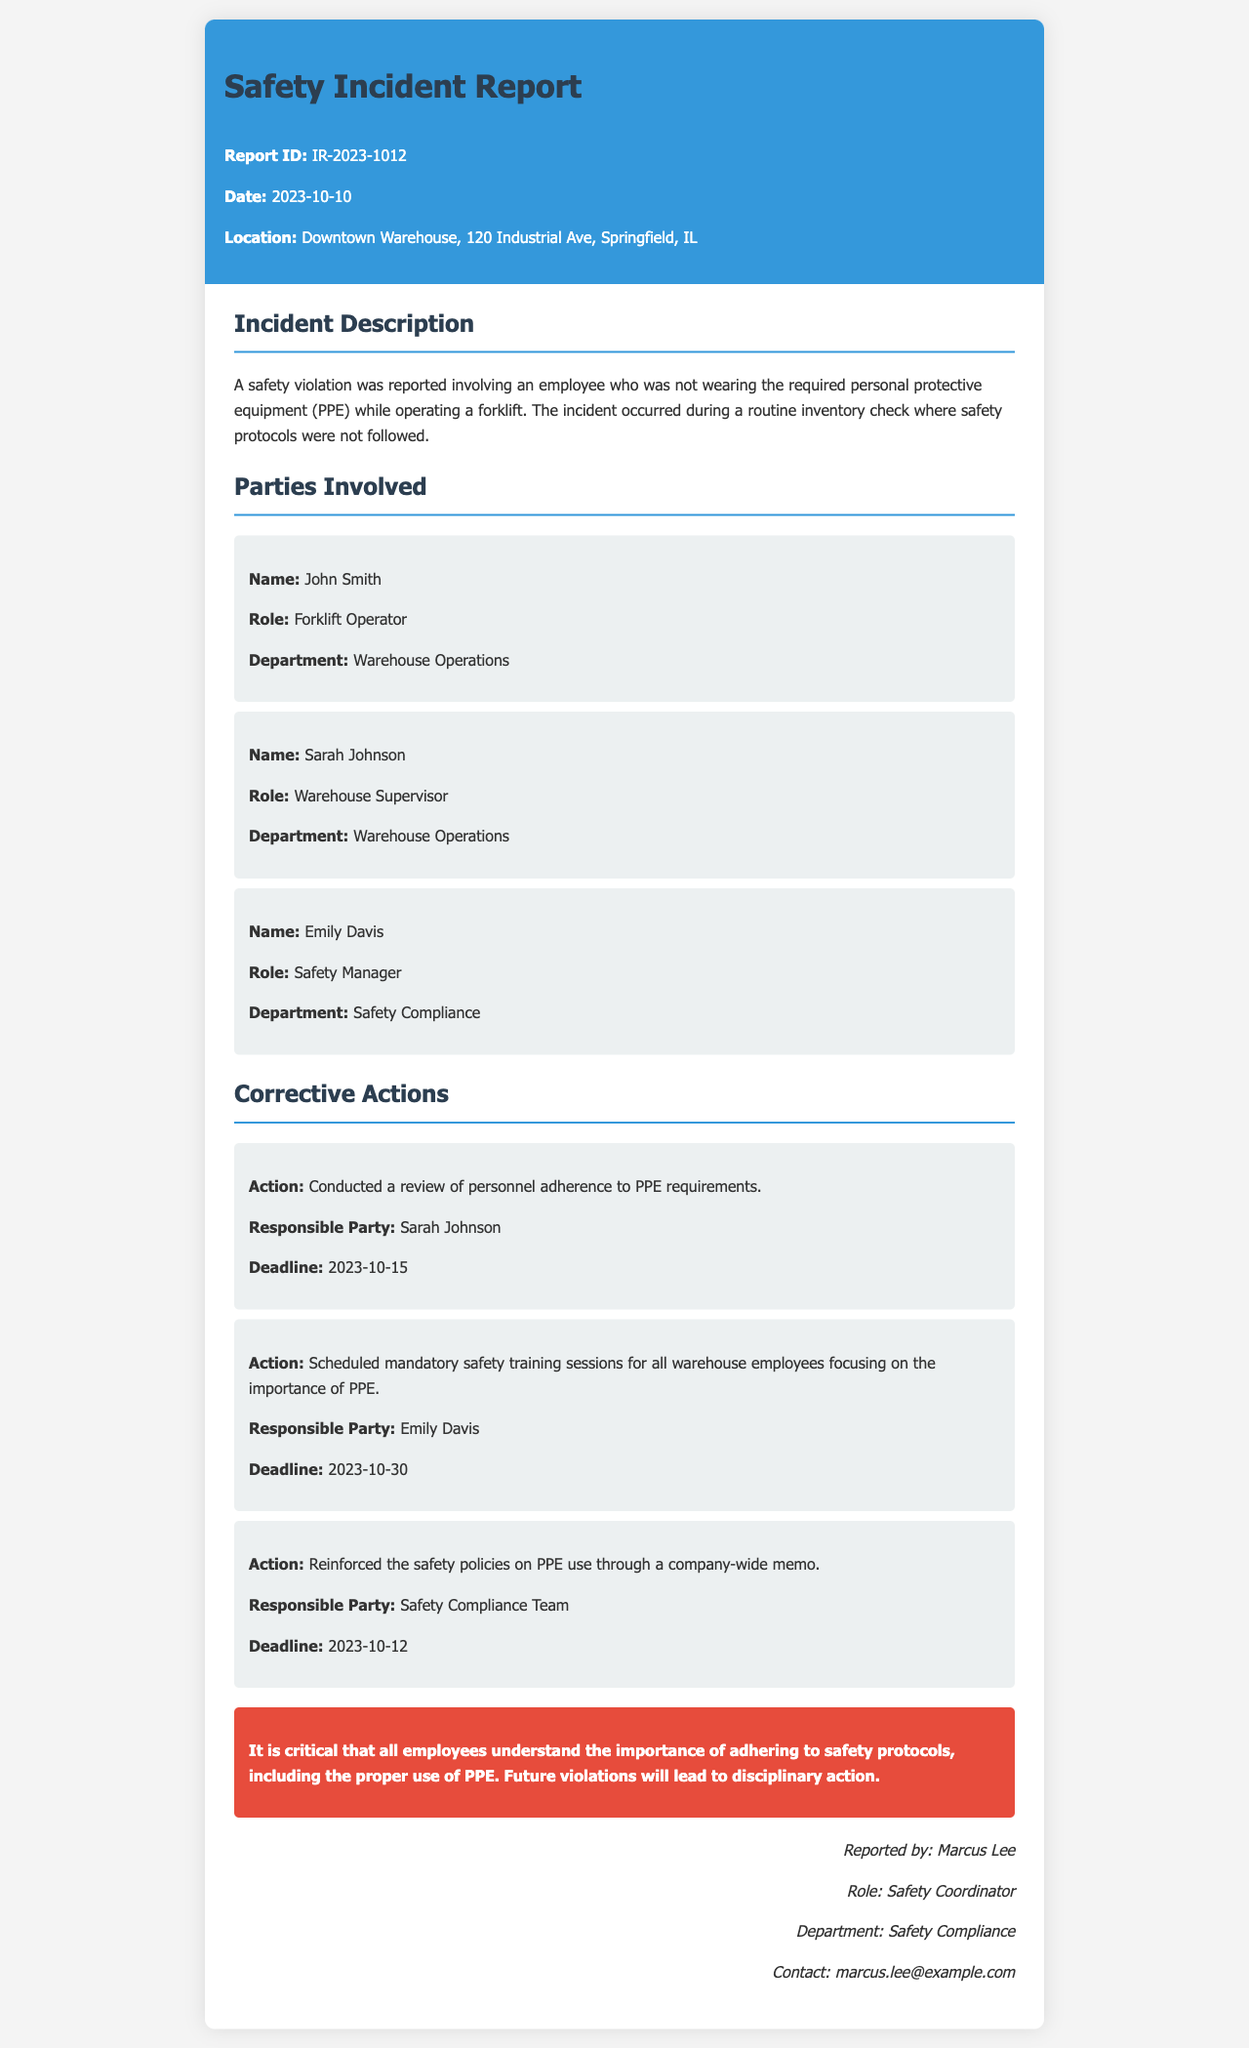What is the report ID? The report ID is specified in the header section of the document.
Answer: IR-2023-1012 Who is the forklift operator involved in the incident? The name of the forklift operator is listed under the parties involved section.
Answer: John Smith What was the date of the incident? The date of the incident is provided in the header section of the document.
Answer: 2023-10-10 What is one of the corrective actions taken? The document outlines several corrective actions taken in response to the incident.
Answer: Conducted a review of personnel adherence to PPE requirements Who is responsible for scheduling mandatory safety training sessions? This responsibility is assigned to a specific party mentioned in the corrective actions section.
Answer: Emily Davis What location did the incident occur at? The location of the incident is indicated in the header section of the document.
Answer: Downtown Warehouse, 120 Industrial Ave, Springfield, IL What is the deadline for reinforcing safety policies through a memo? The deadline for this action is specified in the corrective actions section of the document.
Answer: 2023-10-12 What is emphasized as critical in the conclusion? The conclusion section summarizes the main points addressed in the report.
Answer: Adhering to safety protocols, including the proper use of PPE 